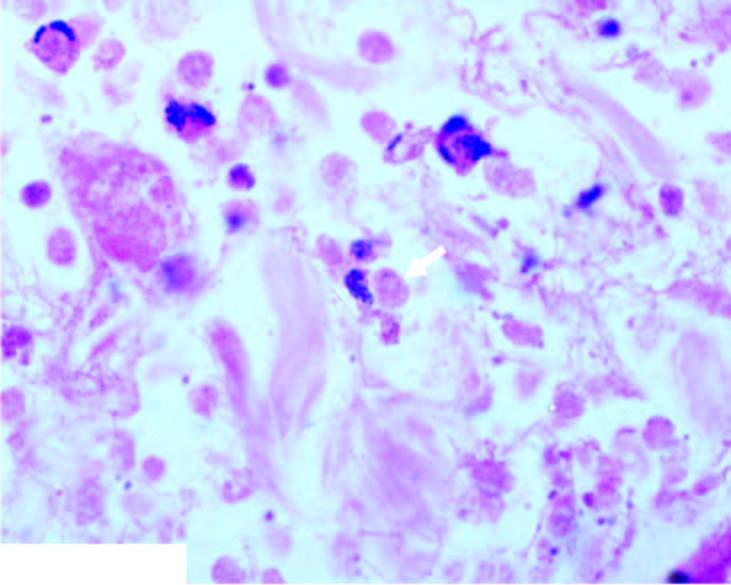what does section from margin of amoebic ulcer show?
Answer the question using a single word or phrase. Necrotic debris 